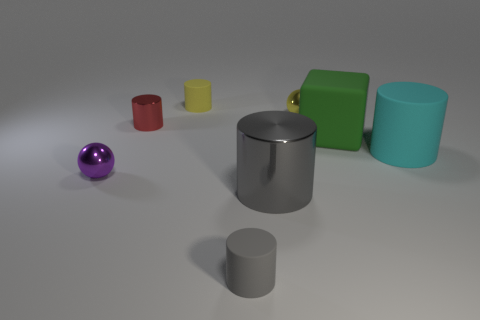This image seems to be digitally rendered. Could you explain any clues that support this? Indeed, the image appears to be a digital rendering. Clues supporting this include the perfectly uniform colors and textures of the objects, the clean and precise edges, and the lack of any imperfections or variations that we would typically see in a photo of real-life objects. Additionally, the shadows and reflections have a synthetic quality indicative of computer-generated imagery. 